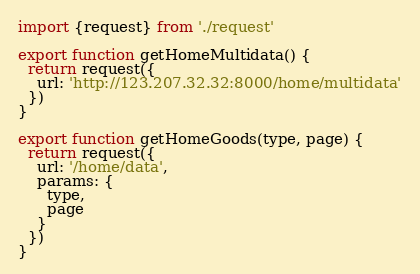Convert code to text. <code><loc_0><loc_0><loc_500><loc_500><_JavaScript_>import {request} from './request'

export function getHomeMultidata() {
  return request({
    url: 'http://123.207.32.32:8000/home/multidata'
  })
}

export function getHomeGoods(type, page) {
  return request({
    url: '/home/data',
    params: {
      type,
      page
    }
  })
}
</code> 